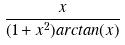Convert formula to latex. <formula><loc_0><loc_0><loc_500><loc_500>\frac { x } { ( 1 + x ^ { 2 } ) a r c t a n ( x ) }</formula> 